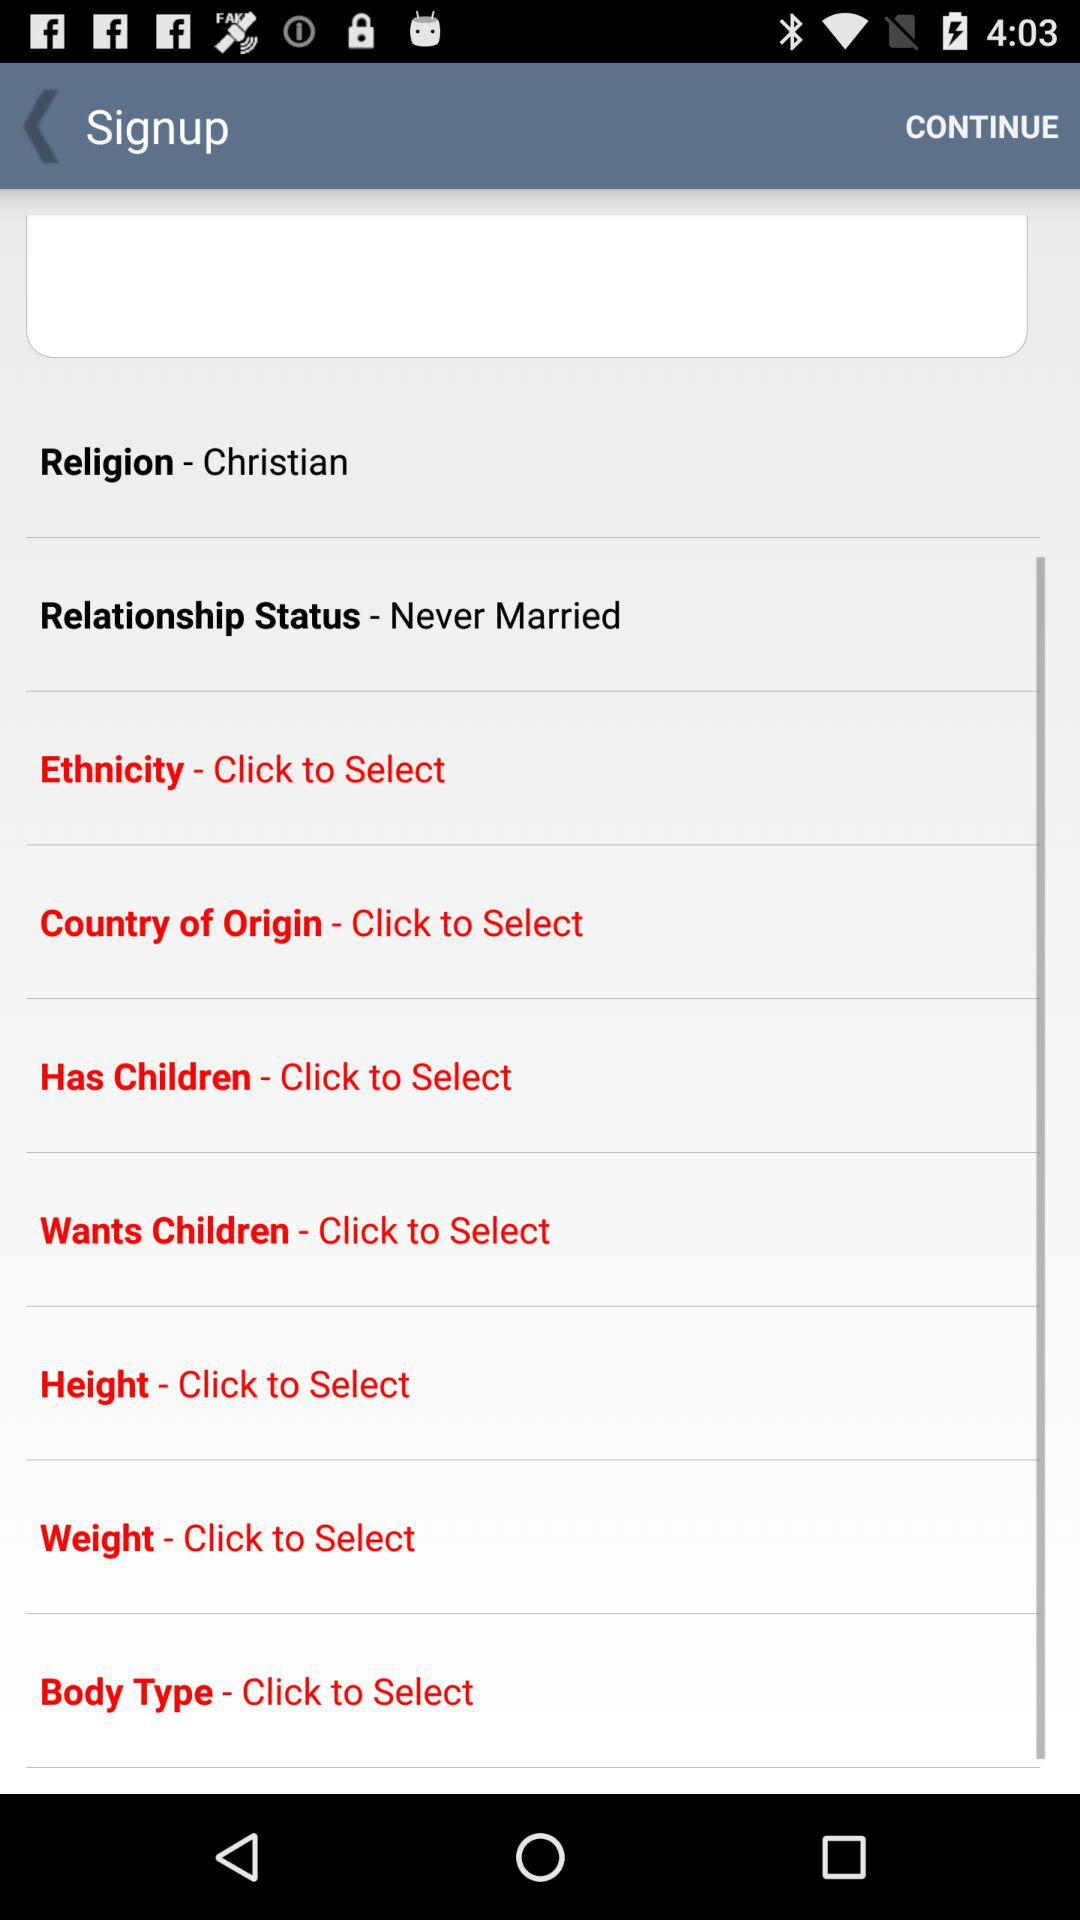What is the shown religion? The religion is "Christian". 